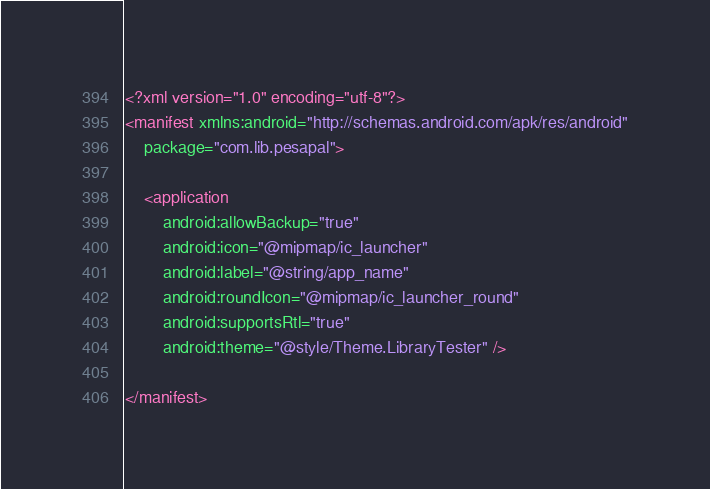Convert code to text. <code><loc_0><loc_0><loc_500><loc_500><_XML_><?xml version="1.0" encoding="utf-8"?>
<manifest xmlns:android="http://schemas.android.com/apk/res/android"
    package="com.lib.pesapal">

    <application
        android:allowBackup="true"
        android:icon="@mipmap/ic_launcher"
        android:label="@string/app_name"
        android:roundIcon="@mipmap/ic_launcher_round"
        android:supportsRtl="true"
        android:theme="@style/Theme.LibraryTester" />

</manifest></code> 